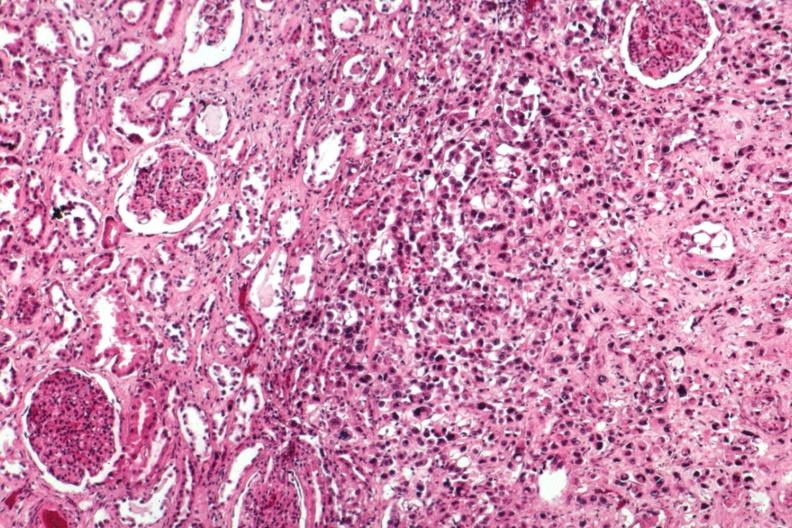what is present?
Answer the question using a single word or phrase. Metastatic carcinoma breast 